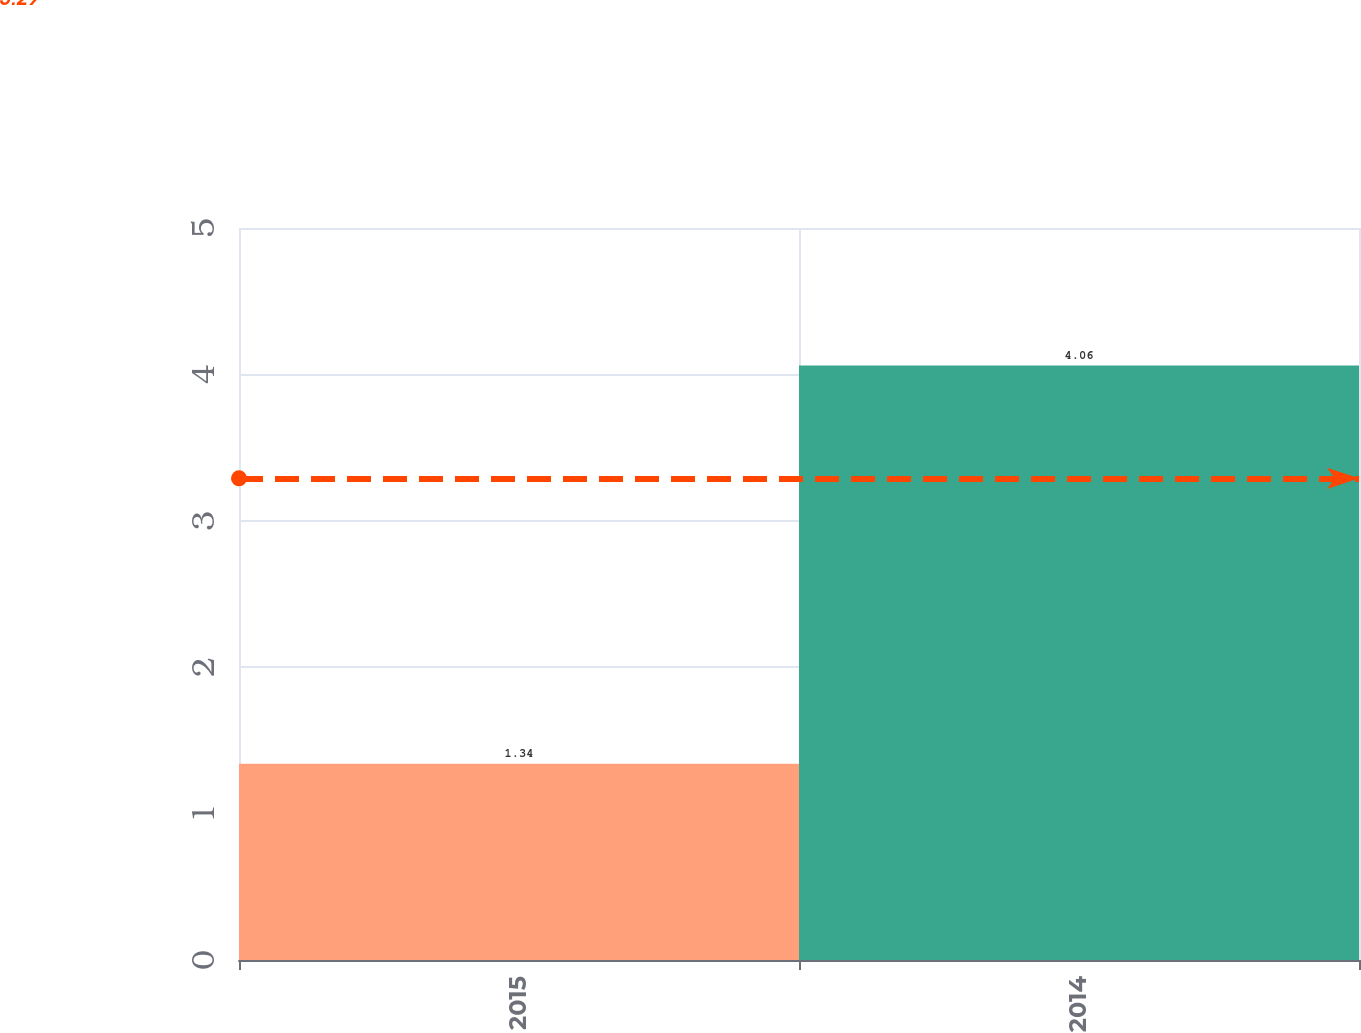Convert chart. <chart><loc_0><loc_0><loc_500><loc_500><bar_chart><fcel>2015<fcel>2014<nl><fcel>1.34<fcel>4.06<nl></chart> 